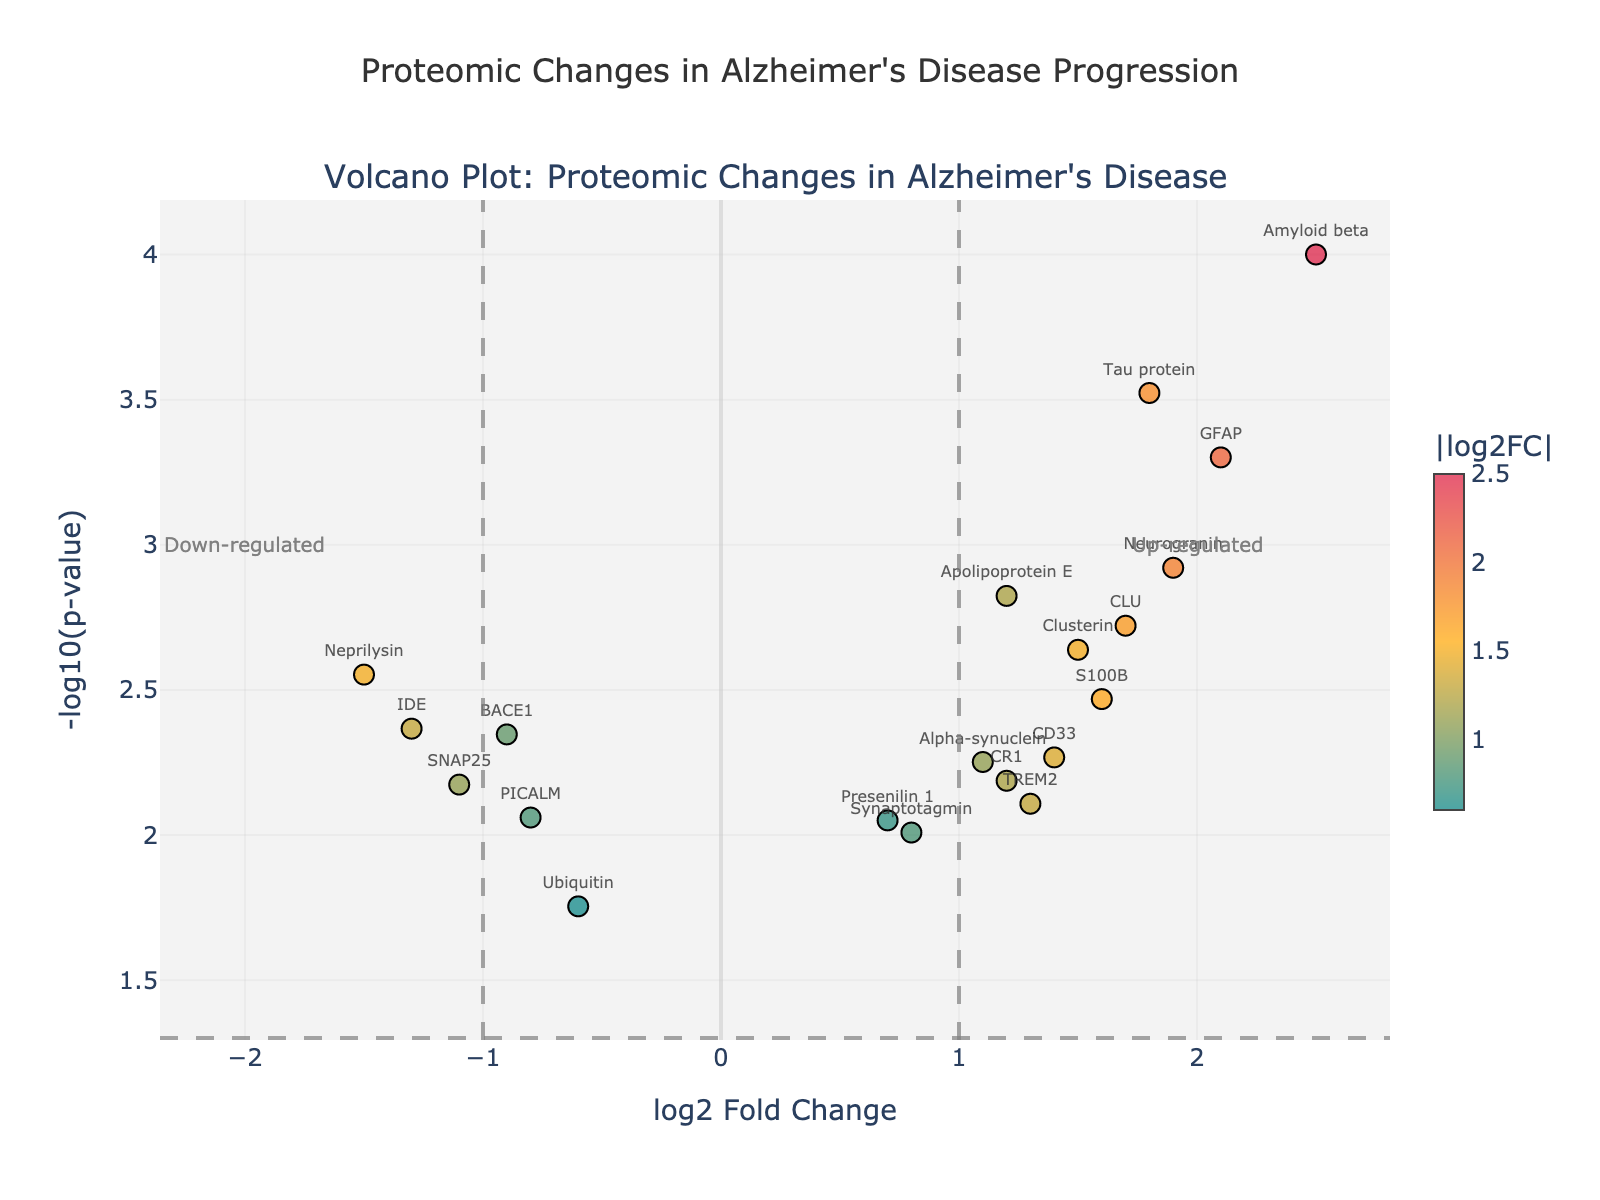What's the title of the figure? The title is displayed at the top center of the figure. It reads "Proteomic Changes in Alzheimer’s Disease Progression."
Answer: Proteomic Changes in Alzheimer’s Disease Progression What does the x-axis represent? The x-axis represents the log2 Fold Change of the proteins, indicating the magnitude of expression changes between conditions.
Answer: log2 Fold Change What does the y-axis represent? The y-axis represents the -log10(p-value), which indicates the statistical significance of the observed changes in protein expression.
Answer: -log10(p-value) Which protein shows the highest log2 Fold Change? By observing the x-axis, the protein with the highest positive log2 Fold Change is "Amyloid beta" at 2.5.
Answer: Amyloid beta How many proteins are significantly upregulated (log2 Fold Change > 1 and p-value < 0.05)? Proteins with log2 Fold Change greater than 1 and y-axis values above the significance threshold line (-log10(p-value) of 0.05) are "Amyloid beta," "Neurogranin," "GFAP," and "Tau protein."
Answer: 4 Which protein has the lowest -log10(p-value)? The protein with the lowest -log10(p-value) is "Ubiquitin," indicated by the smallest value on the y-axis.
Answer: Ubiquitin Is "Synaptotagmin" significantly differentially expressed? "Synaptotagmin" is not above the significance threshold line (y=-log10(p-value) of 0.05) and does not meet the vertical cutoff lines at log2 Fold Change of 1 or -1.
Answer: No Compare "Amyloid beta" and "BACE1" log2 Fold Change values. Which one has a higher absolute fold change? "Amyloid beta" has a log2 Fold Change of 2.5, and "BACE1" has -0.9. Since 2.5 > 0.9, "Amyloid beta" has a higher absolute fold change.
Answer: Amyloid beta What quadrant do "Neprilysin" and "IDE" fall into based on their log2 Fold Change and significance? Both proteins have negative log2 Fold Changes and are above the significance threshold line. "Neprilysin" has -1.5, and "IDE" has -1.3, so they fall into the down-regulated quadrant.
Answer: Down-regulated Describe the color significance in the figure. The colors range from teal to orange to red, corresponding to increasing absolute values of log2 Fold Change. Proteins with higher absolute changes appear in warmer colors.
Answer: Indicates log2 Fold Change 